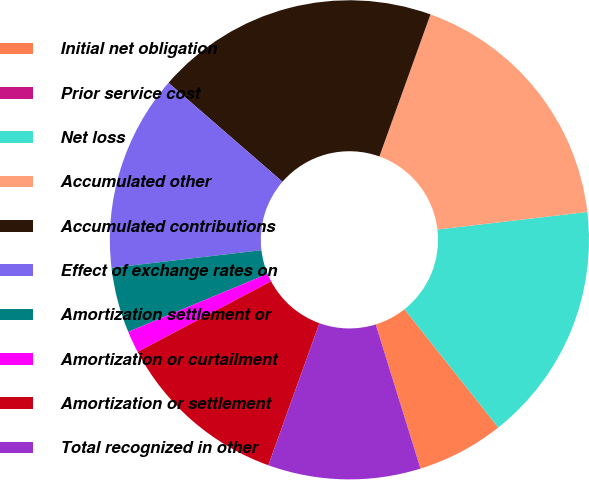<chart> <loc_0><loc_0><loc_500><loc_500><pie_chart><fcel>Initial net obligation<fcel>Prior service cost<fcel>Net loss<fcel>Accumulated other<fcel>Accumulated contributions<fcel>Effect of exchange rates on<fcel>Amortization settlement or<fcel>Amortization or curtailment<fcel>Amortization or settlement<fcel>Total recognized in other<nl><fcel>5.88%<fcel>0.0%<fcel>16.18%<fcel>17.65%<fcel>19.12%<fcel>13.24%<fcel>4.41%<fcel>1.47%<fcel>11.76%<fcel>10.29%<nl></chart> 